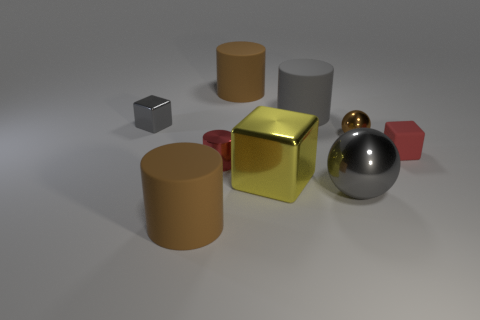Subtract 1 cylinders. How many cylinders are left? 3 Add 1 metal things. How many objects exist? 10 Subtract all cylinders. How many objects are left? 5 Subtract 0 red spheres. How many objects are left? 9 Subtract all brown metallic objects. Subtract all small cylinders. How many objects are left? 7 Add 2 large gray rubber cylinders. How many large gray rubber cylinders are left? 3 Add 7 tiny yellow rubber cylinders. How many tiny yellow rubber cylinders exist? 7 